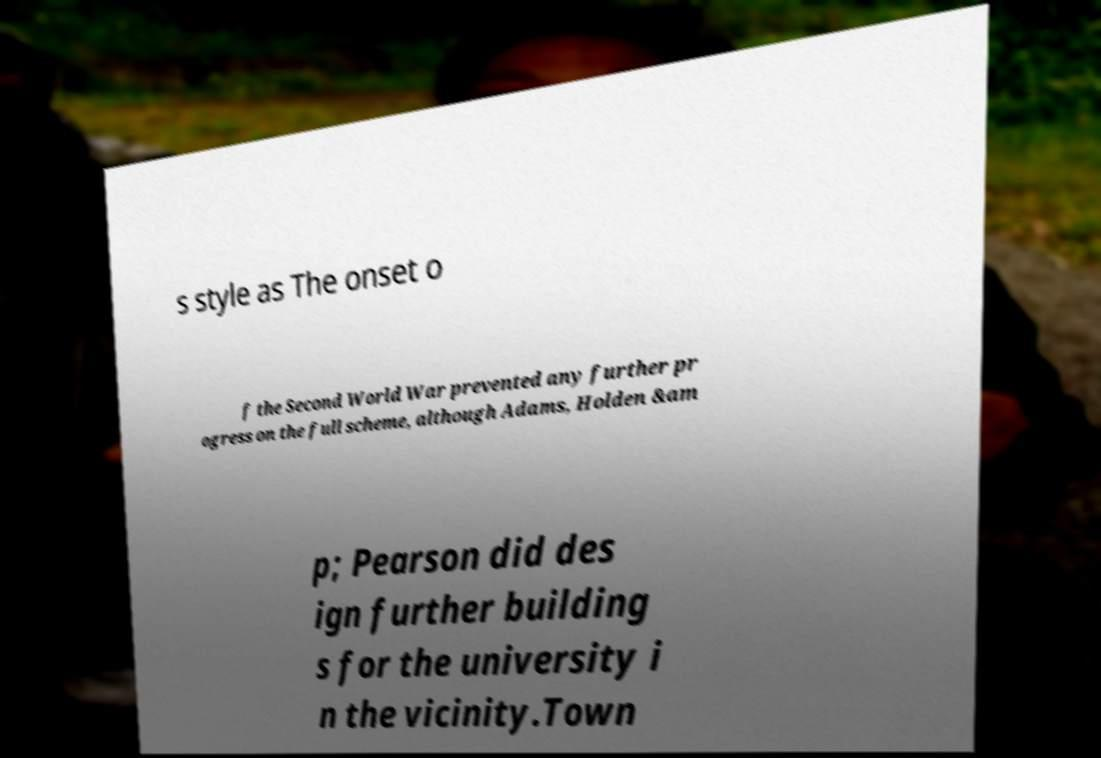For documentation purposes, I need the text within this image transcribed. Could you provide that? s style as The onset o f the Second World War prevented any further pr ogress on the full scheme, although Adams, Holden &am p; Pearson did des ign further building s for the university i n the vicinity.Town 